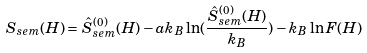<formula> <loc_0><loc_0><loc_500><loc_500>S _ { s e m } ( H ) = \hat { S } _ { s e m } ^ { ( 0 ) } ( H ) - a k _ { B } \ln ( \frac { \hat { S } _ { s e m } ^ { ( 0 ) } ( H ) } { k _ { B } } ) - k _ { B } \ln F ( H )</formula> 